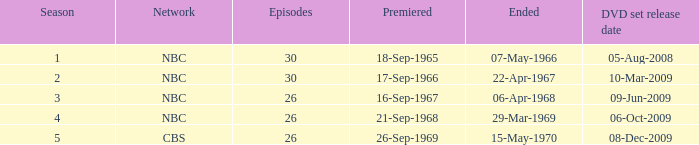When dis cbs release the DVD set? 08-Dec-2009. 